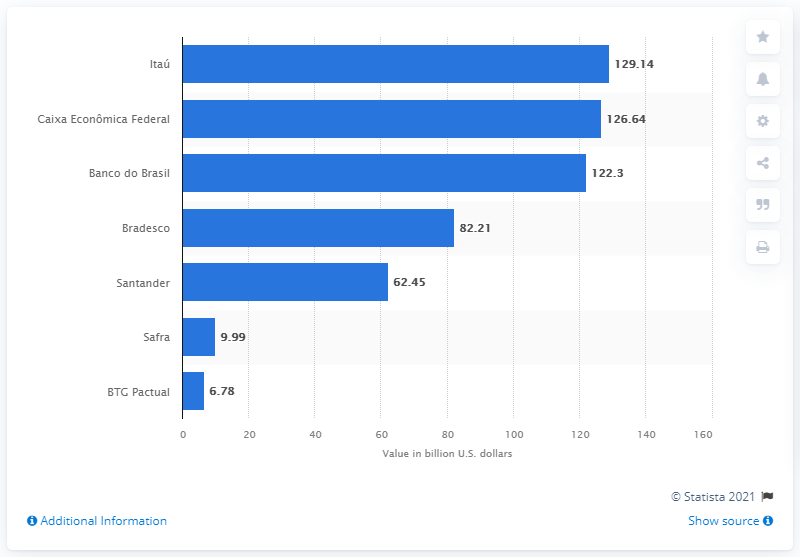How many dollars did Itau Unibanco deposit as of September 2019? As of September 2019, Itau Unibanco reported deposits amounting to 129.14 billion U.S. dollars, leading among Brazilian banks as depicted in the bar graph. 